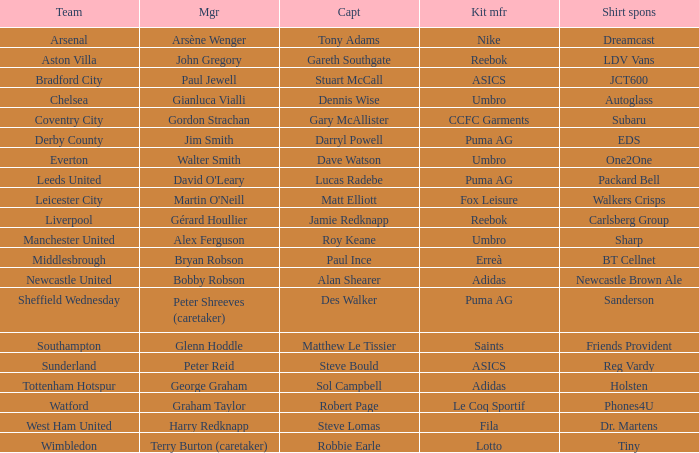Which captain is under the management of gianluca vialli? Dennis Wise. 